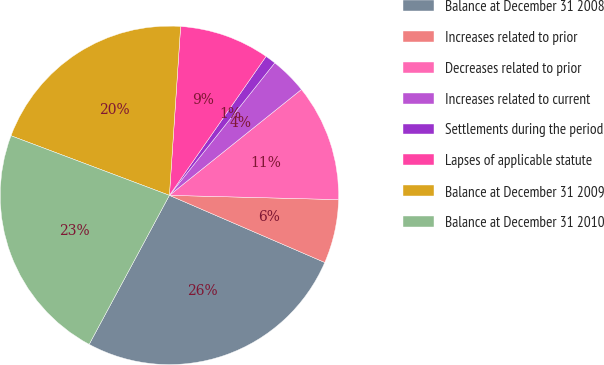Convert chart. <chart><loc_0><loc_0><loc_500><loc_500><pie_chart><fcel>Balance at December 31 2008<fcel>Increases related to prior<fcel>Decreases related to prior<fcel>Increases related to current<fcel>Settlements during the period<fcel>Lapses of applicable statute<fcel>Balance at December 31 2009<fcel>Balance at December 31 2010<nl><fcel>26.37%<fcel>6.09%<fcel>11.16%<fcel>3.55%<fcel>1.02%<fcel>8.62%<fcel>20.33%<fcel>22.87%<nl></chart> 